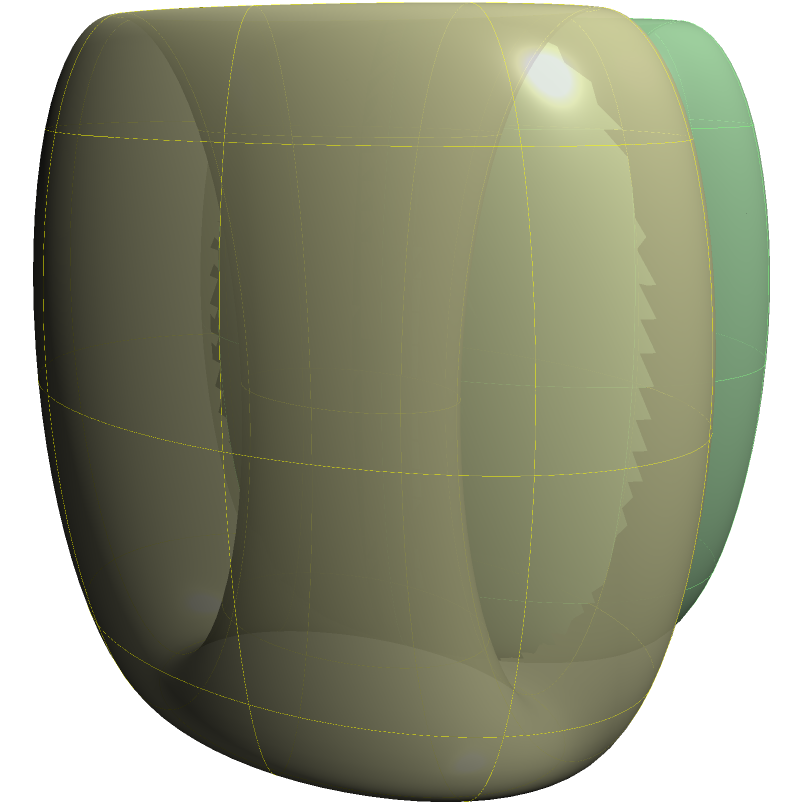Consider the two surfaces shown in the figure above. Both are tori (donut shapes) with different sizes. Given that a torus is an orientable surface with genus 1, determine the Euler characteristic $\chi$ for each of these surfaces and explain how this relates to their classification in topology. To solve this problem, we'll follow these steps:

1. Recall the definition of Euler characteristic:
   The Euler characteristic $\chi$ is defined as $\chi = V - E + F$, where V is the number of vertices, E is the number of edges, and F is the number of faces in a triangulation of the surface.

2. For orientable surfaces, the Euler characteristic is related to the genus g by the formula:
   $\chi = 2 - 2g$

3. We know that a torus has genus g = 1. Let's substitute this into the formula:
   $\chi = 2 - 2(1) = 2 - 2 = 0$

4. Therefore, both tori in the figure have an Euler characteristic of 0, regardless of their size.

5. In topology, surfaces are classified based on their genus and orientability. The Euler characteristic is a topological invariant, meaning it doesn't change under continuous deformations of the surface.

6. The fact that both tori have the same Euler characteristic (0) indicates that they are topologically equivalent, despite their different sizes. This is a key principle in topology: geometric properties like size and exact shape can vary, but topological properties remain constant under continuous transformations.

7. In the classification of orientable surfaces, all tori (regardless of size) fall into the same topological class, characterized by genus 1 and Euler characteristic 0.
Answer: $\chi = 0$ for both tori; topologically equivalent 